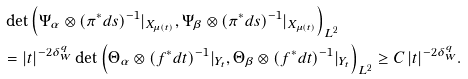Convert formula to latex. <formula><loc_0><loc_0><loc_500><loc_500>\, & \det \left ( { \Psi } _ { \alpha } \otimes ( \pi ^ { * } d s ) ^ { - 1 } | _ { X _ { \mu ( t ) } } , { \Psi } _ { \beta } \otimes ( \pi ^ { * } d s ) ^ { - 1 } | _ { X _ { \mu ( t ) } } \right ) _ { L ^ { 2 } } \\ & = | t | ^ { - 2 \delta _ { W } ^ { q } } \det \left ( { \Theta } _ { \alpha } \otimes ( f ^ { * } d t ) ^ { - 1 } | _ { Y _ { t } } , { \Theta } _ { \beta } \otimes ( f ^ { * } d t ) ^ { - 1 } | _ { Y _ { t } } \right ) _ { L ^ { 2 } } \geq C \, | t | ^ { - 2 \delta _ { W } ^ { q } } .</formula> 